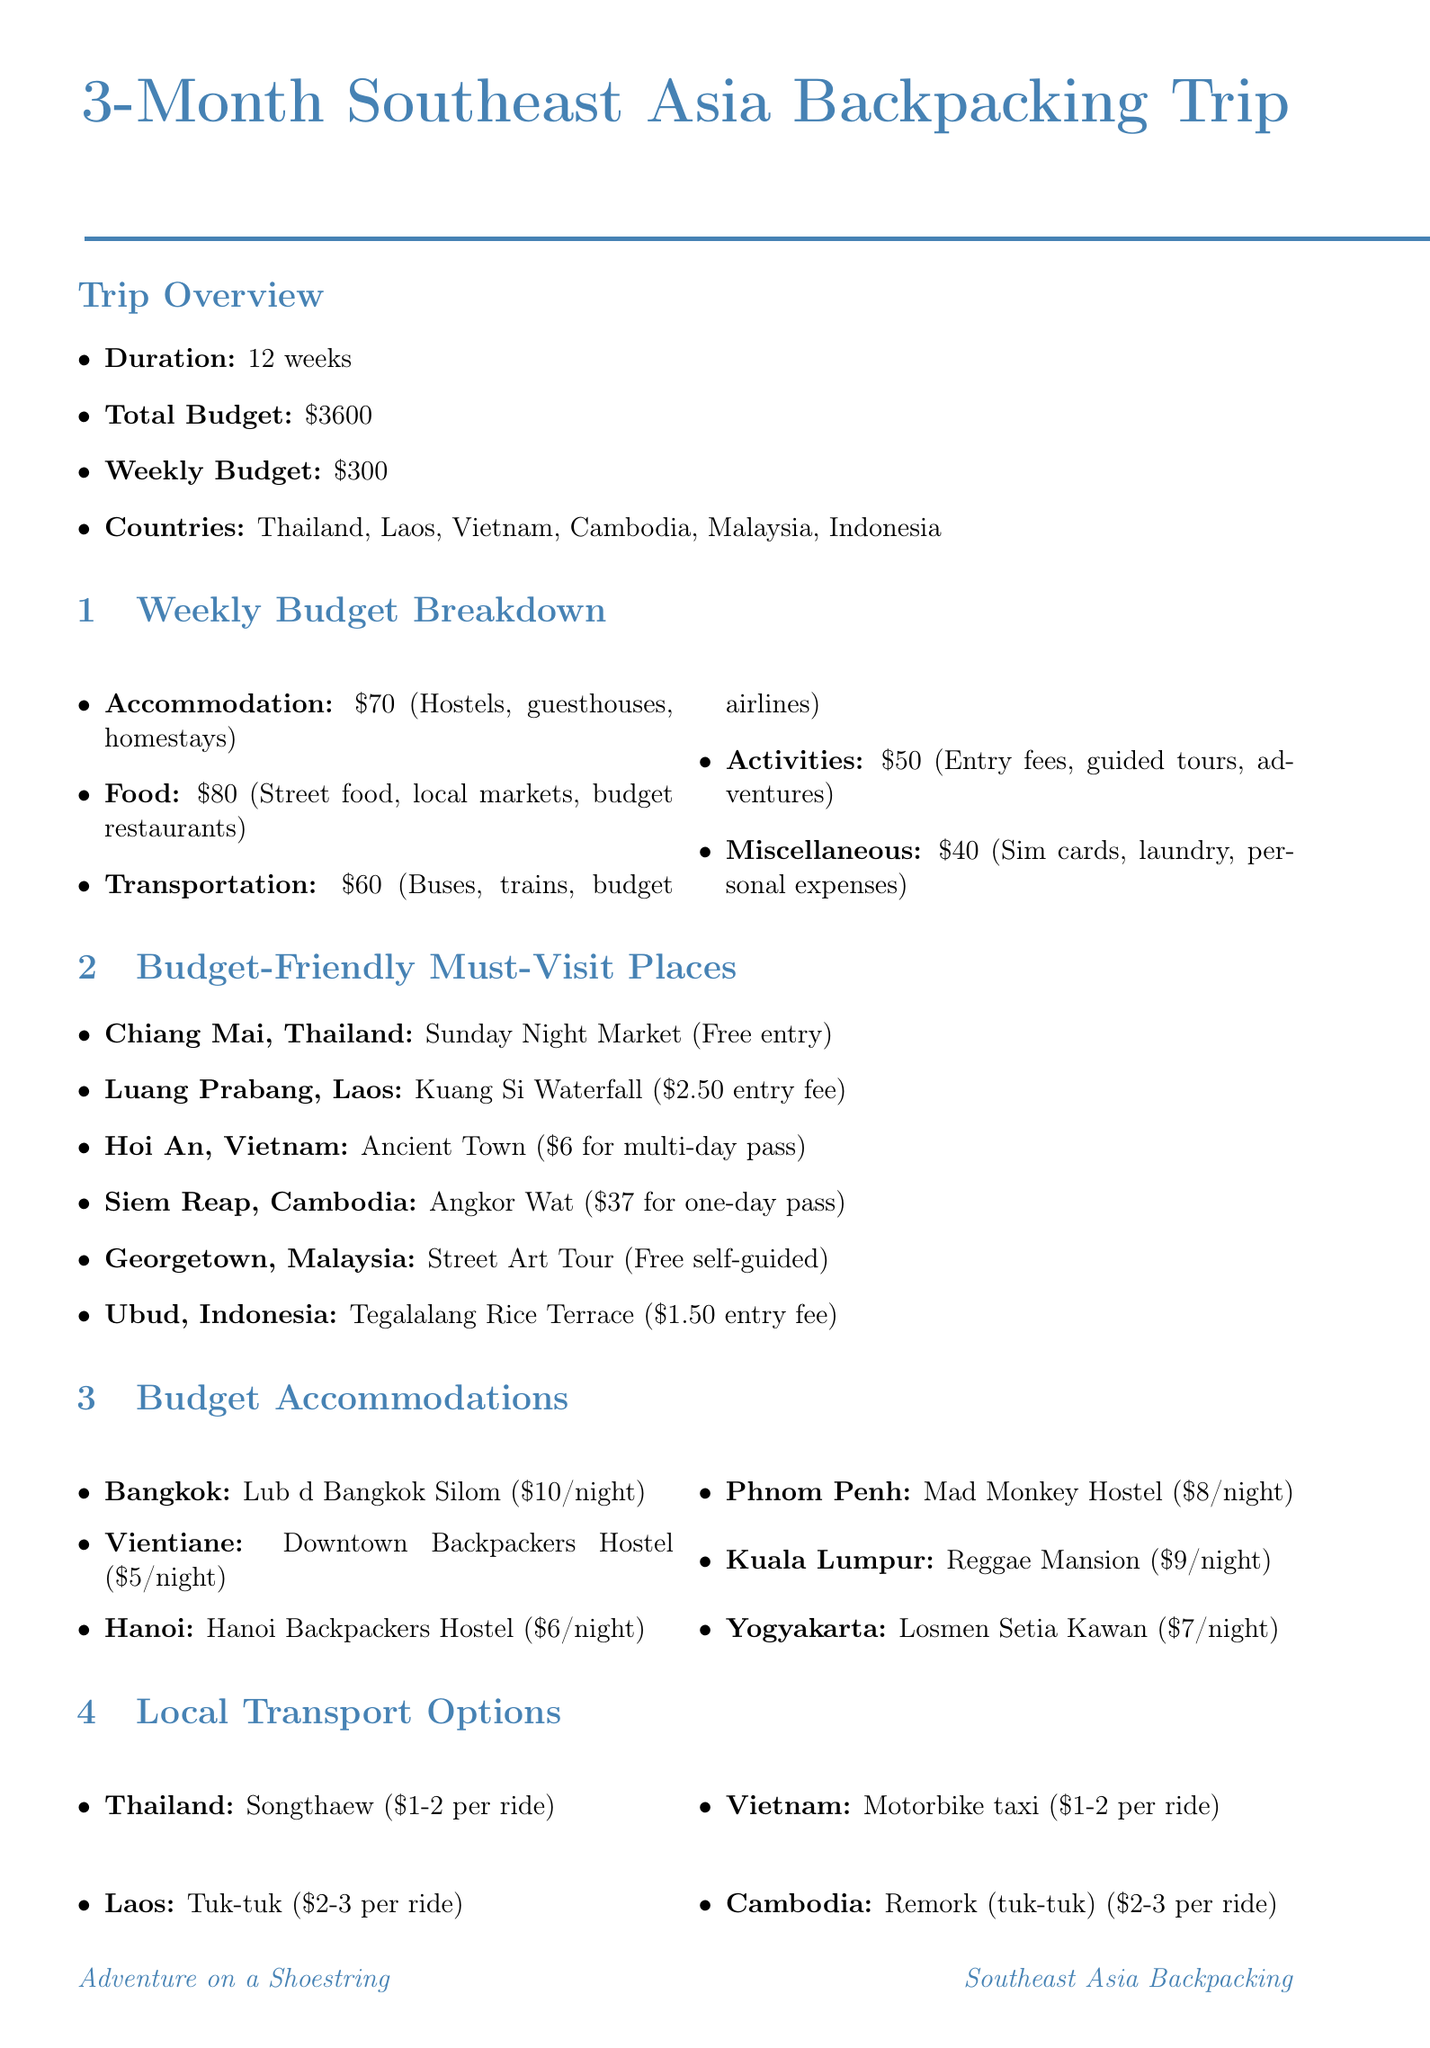What is the trip duration? The trip duration is specified in the document as 12 weeks.
Answer: 12 weeks What is the total budget for the trip? The total budget is provided in the document as $3600.
Answer: $3600 How much is allocated for food each week? The weekly budget breakdown shows that the amount for food is $80.
Answer: $80 What is the entry fee for Angkor Wat? The document indicates that the entry fee for Angkor Wat is $37 for a one-day pass.
Answer: $37 Which country has the local transport option "Ojek"? The document lists "Ojek (motorcycle taxi)" under local transport options for Indonesia.
Answer: Indonesia How much does a night at Downtown Backpackers Hostel cost? The document specifies the cost per night at Downtown Backpackers Hostel as $5.
Answer: $5 What is one tip mentioned for saving money on transportation? The document provides several tips, one of which is to use night buses for long-distance travel to save on accommodation.
Answer: Use night buses Name one budget-friendly attraction in Malaysia. The document mentions the Street Art Tour in Georgetown, Malaysia, which is a free self-guided tour.
Answer: Street Art Tour What is the average cost for a Songthaew ride in Thailand? The average cost for a Songthaew ride is listed as $1-2 per ride in the document.
Answer: $1-2 per ride 